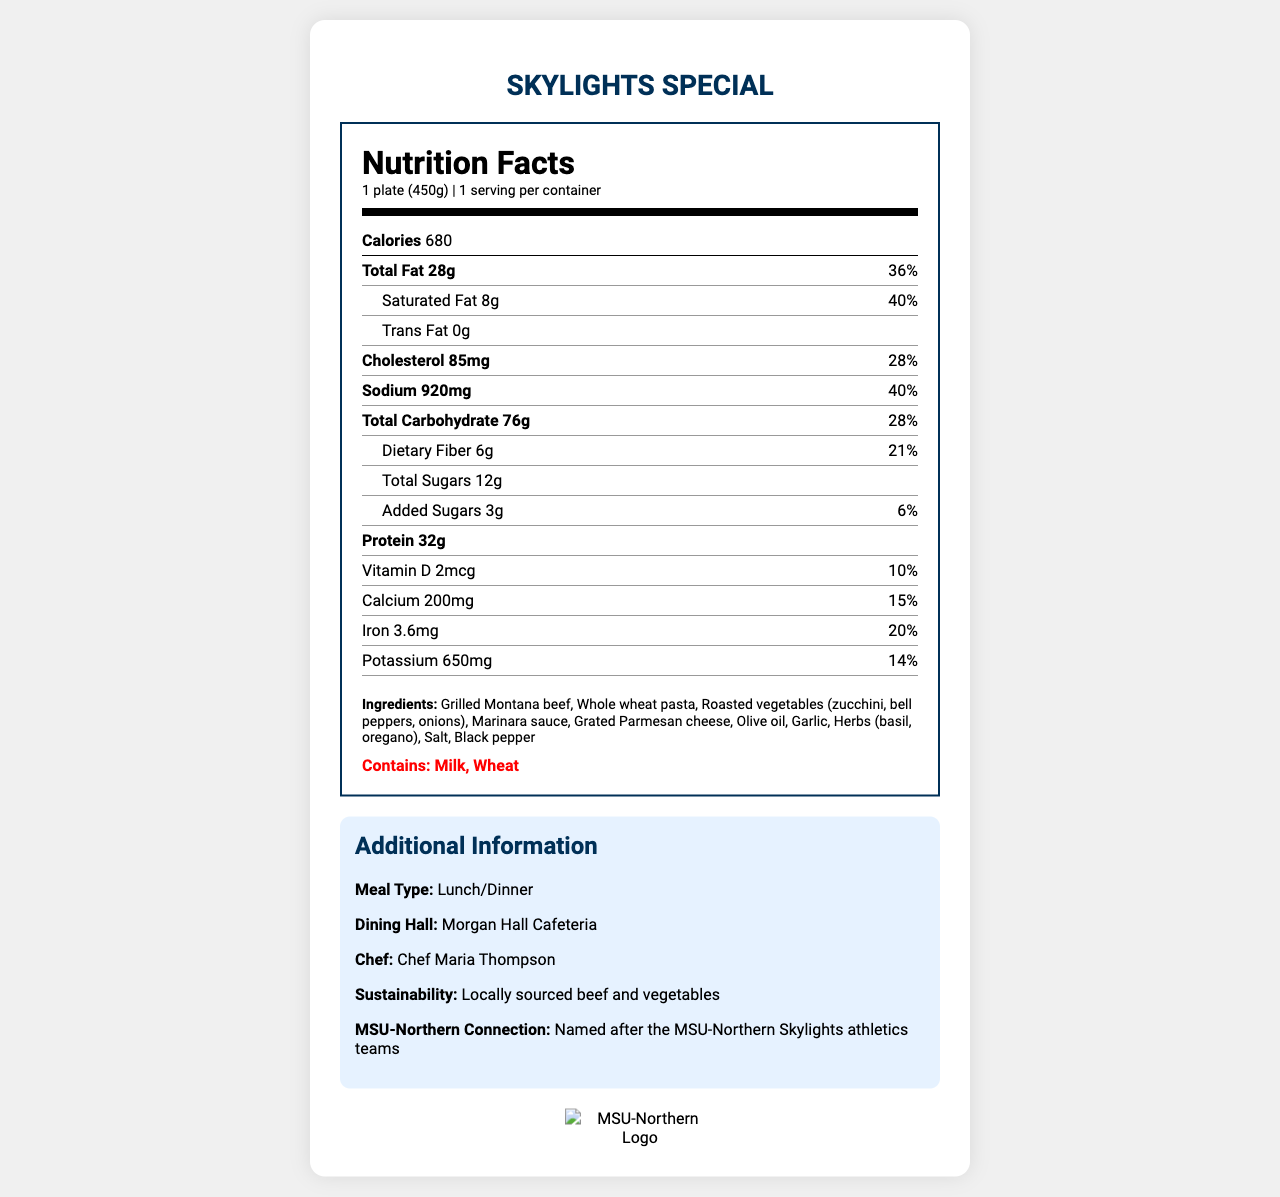what is the serving size for the Skylights Special? The serving size is clearly labeled as "1 plate (450g)" in the nutrition facts.
Answer: 1 plate (450g) how many calories are in one serving of the Skylights Special? The calories are stated as 680 in the nutrition facts section for one serving of the Skylights Special.
Answer: 680 what is the chef's name for the Skylights Special? The "Additional Information" section states that the chef who prepared the Skylights Special is Chef Maria Thompson.
Answer: Chef Maria Thompson what percentage of the daily value of sodium is in one serving? The nutrition facts label clearly states that the sodium amount is 920 mg, which is 40% of the daily value.
Answer: 40% list the allergens contained in the Skylights Special. The allergens are listed as "Milk" and "Wheat" in a bold section in the nutrition facts label.
Answer: Milk, Wheat which vitamins and minerals have their daily values provided, and what are those values? A. Vitamin D: 10%, Calcium: 15%, Iron: 20%, Potassium: 14% B. Vitamin D: 15%, Calcium: 10%, Iron: 20%, Potassium: 14% C. Vitamin D: 20%, Calcium: 10%, Iron: 15%, Potassium: 14% The daily values for Vitamin D, Calcium, Iron, and Potassium are listed as 10%, 15%, 20%, and 14% respectively.
Answer: A. Vitamin D: 10%, Calcium: 15%, Iron: 20%, Potassium: 14% how many grams of dietary fiber are in one serving? A. 4g B. 5g C. 6g D. 7g The nutrient label shows that there are 6 grams of dietary fiber in one serving of the Skylights Special.
Answer: C. 6g is there any trans fat in the Skylights Special? The label specifies that there are 0 grams of trans fat in the Skylights Special.
Answer: No describe the main idea of the document. This document is a comprehensive nutrition facts label for the Skylights Special meal, giving detailed nutritional values, ingredients, allergens, and some additional information about its preparation and connection to MSU-Northern.
Answer: The document provides detailed nutritional information about the Skylights Special meal offered at the Morgan Hall Cafeteria, including calories, fat, cholesterol, sodium, carbohydrate, protein, and vitamins. It also lists ingredients and allergens, and provides additional information about the meal's sustainability and connection to Montana State University-Northern. does the Skylights Special contain any added sugars? The nutrition label indicates that the Skylights Special contains 3 grams of added sugars, which is 6% of the daily value.
Answer: Yes, 3g what are the main ingredients in the Skylights Special? The ingredients listed in the nutrition facts label include Grilled Montana beef, Whole wheat pasta, Roasted vegetables, etc.
Answer: Grilled Montana beef, Whole wheat pasta, Roasted vegetables (zucchini, bell peppers, onions), Marinara sauce, Grated Parmesan cheese, Olive oil, Garlic, Herbs (basil, oregano), Salt, Black pepper what is the sustainability claim associated with the Skylights Special? The additional information section mentions that the Skylights Special uses locally sourced beef and vegetables as part of its sustainability efforts.
Answer: Locally sourced beef and vegetables which dining hall serves the Skylights Special? The additional information section states that the Skylights Special is served at the Morgan Hall Cafeteria.
Answer: Morgan Hall Cafeteria what percentage of the daily value does saturated fat contribute? The nutrition facts label clearly indicates that the saturated fat content contributes 40% to the daily value.
Answer: 40% how many grams of protein does the Skylights Special have per serving? The nutrition facts state that the Skylights Special contains 32 grams of protein per serving.
Answer: 32g does the Skylights Special have any connection to MSU-Northern? The additional information section indicates that the Skylights Special is named in reference to the MSU-Northern Skylights athletics teams.
Answer: Yes, it is named after the MSU-Northern Skylights athletics teams what is the percentage of dietary fiber per serving? The label states that the dietary fiber content is 6 grams, which accounts for 21% of the daily value.
Answer: 21% does the meal have a high amount of cholesterol? The meal contains 85 mg of cholesterol, which is 28% of the daily value.
Answer: 85mg, 28% 